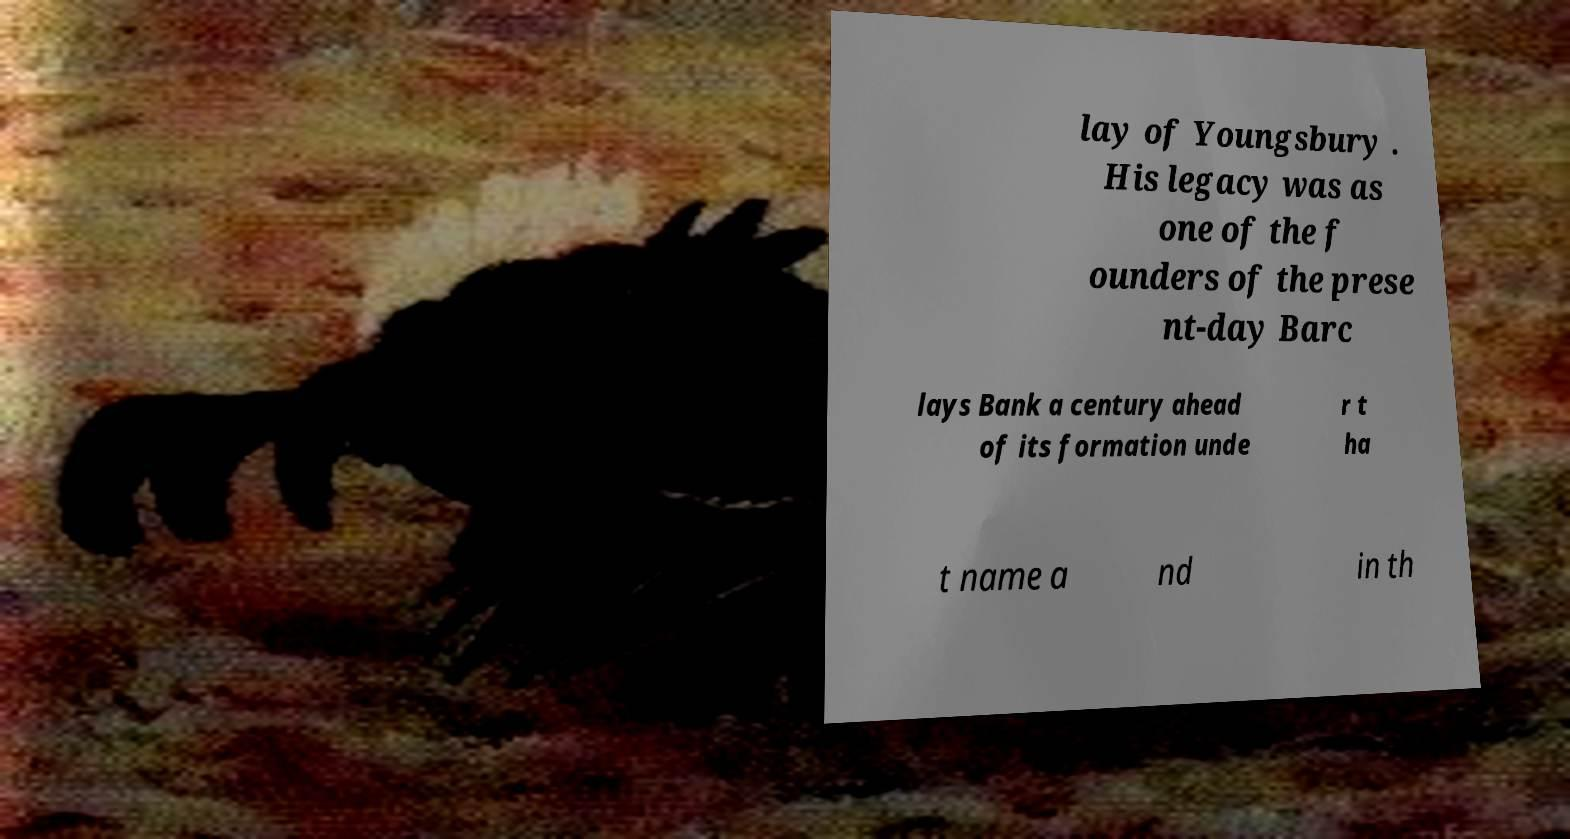What messages or text are displayed in this image? I need them in a readable, typed format. lay of Youngsbury . His legacy was as one of the f ounders of the prese nt-day Barc lays Bank a century ahead of its formation unde r t ha t name a nd in th 